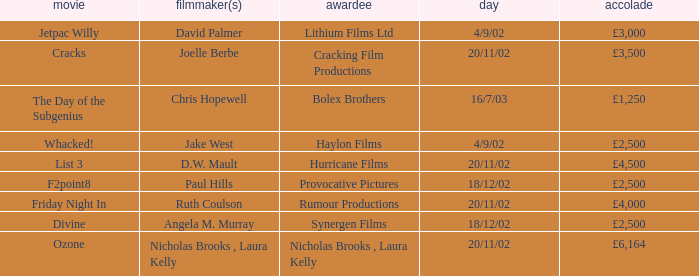What award did the film Ozone win? £6,164. 